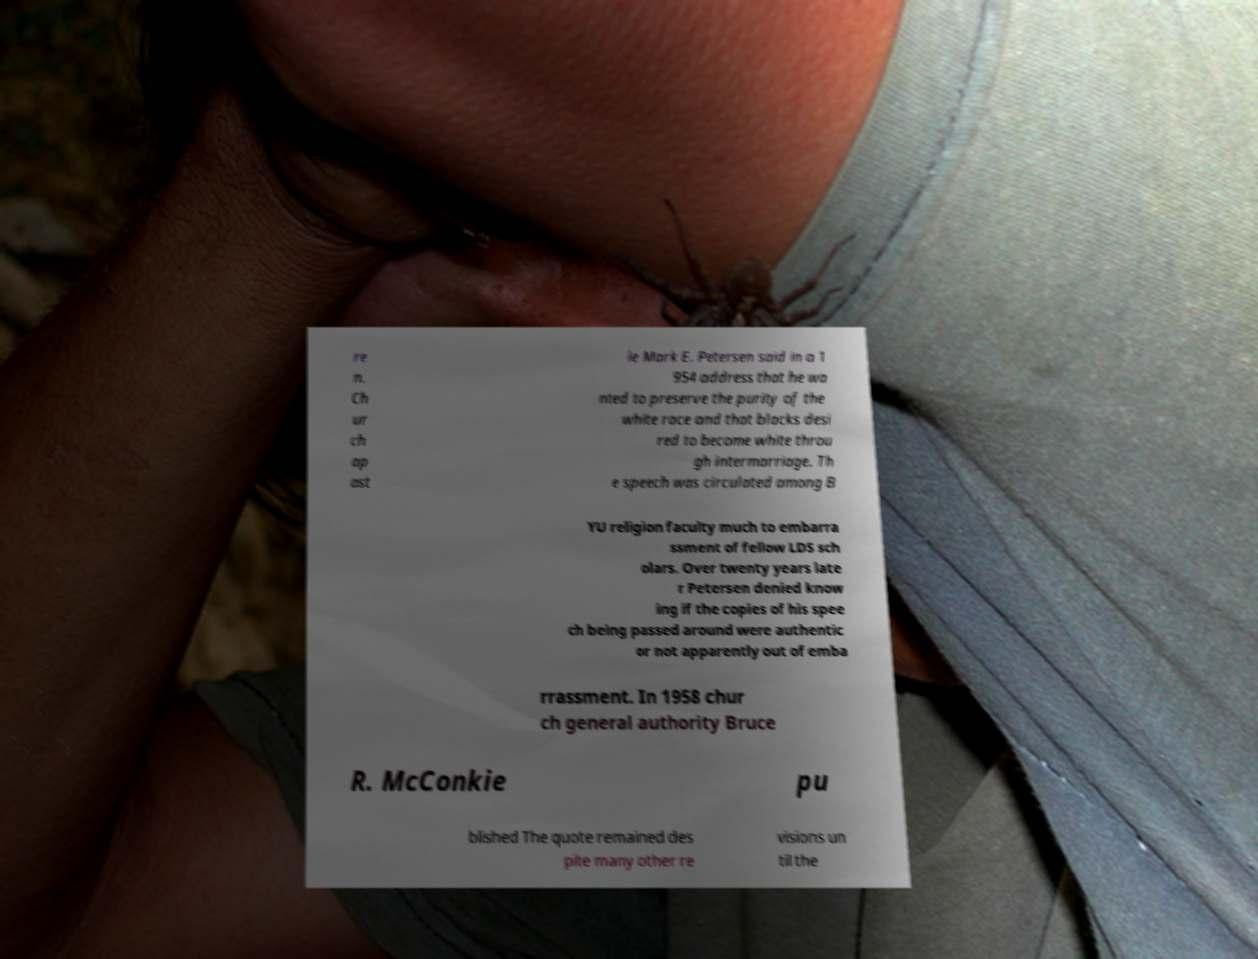Can you accurately transcribe the text from the provided image for me? re n. Ch ur ch ap ost le Mark E. Petersen said in a 1 954 address that he wa nted to preserve the purity of the white race and that blacks desi red to become white throu gh intermarriage. Th e speech was circulated among B YU religion faculty much to embarra ssment of fellow LDS sch olars. Over twenty years late r Petersen denied know ing if the copies of his spee ch being passed around were authentic or not apparently out of emba rrassment. In 1958 chur ch general authority Bruce R. McConkie pu blished The quote remained des pite many other re visions un til the 